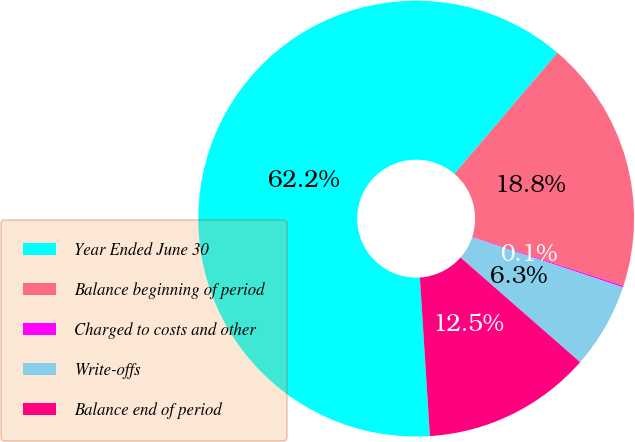Convert chart. <chart><loc_0><loc_0><loc_500><loc_500><pie_chart><fcel>Year Ended June 30<fcel>Balance beginning of period<fcel>Charged to costs and other<fcel>Write-offs<fcel>Balance end of period<nl><fcel>62.24%<fcel>18.76%<fcel>0.12%<fcel>6.34%<fcel>12.55%<nl></chart> 